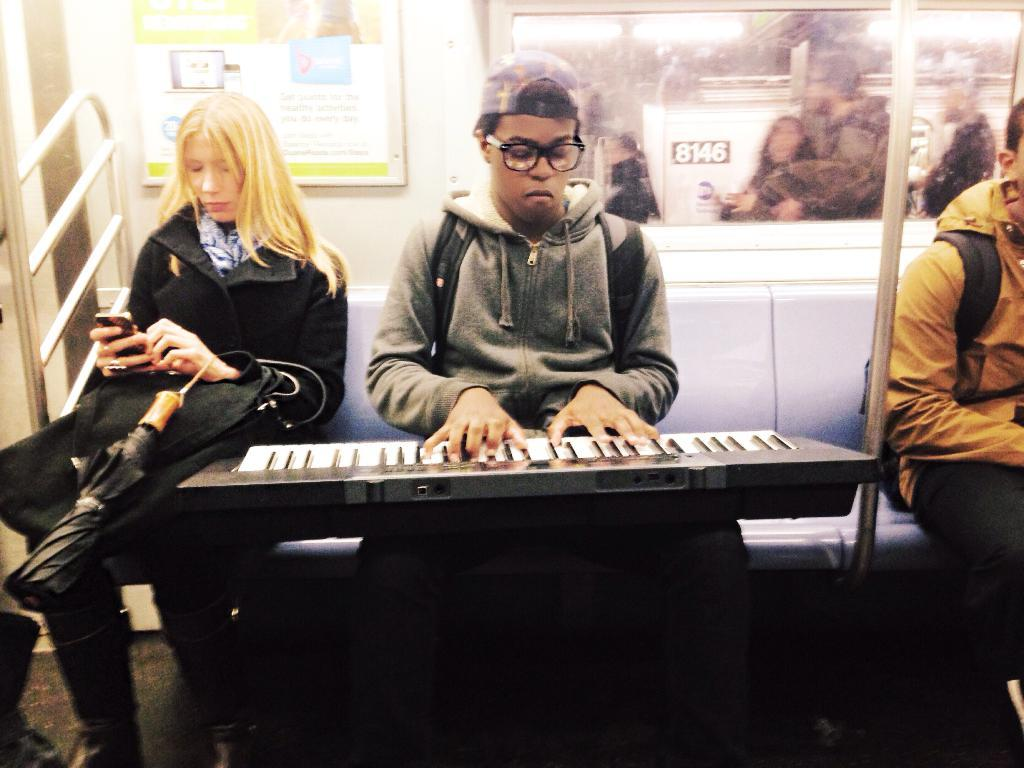What is the man doing in the image? The man is playing a piano keyboard in the image. Can you describe the woman in the image? The woman is holding an umbrella and a mobile in the image. What is the setting of the image? The image is inside a train, and there is a window in the train. What can be seen through the window? Persons are visible through the window in the image. What type of necklace is the woman wearing in the image? There is no mention of a necklace in the provided facts, so we cannot determine if the woman is wearing a necklace. What is the woman doing to prepare for the war in the image? There is no mention of war in the provided facts, so we cannot determine if the woman is preparing for a war in the image. 